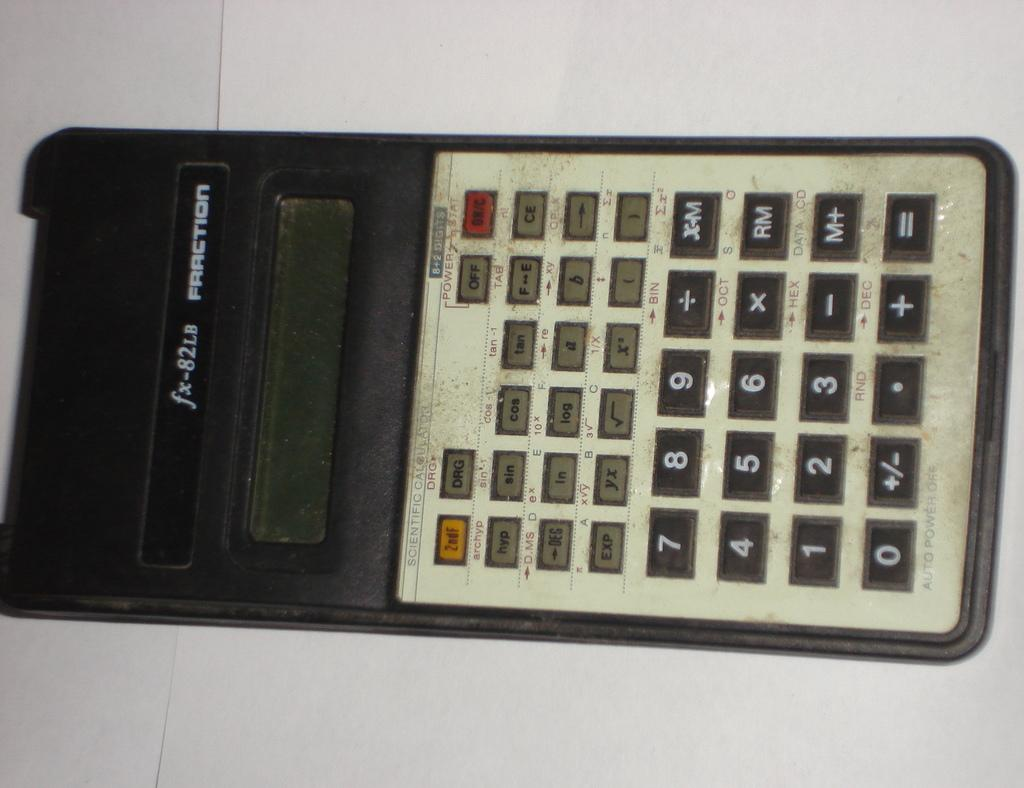Provide a one-sentence caption for the provided image. A dirty Fraction brand scientific calculator is turned off. 